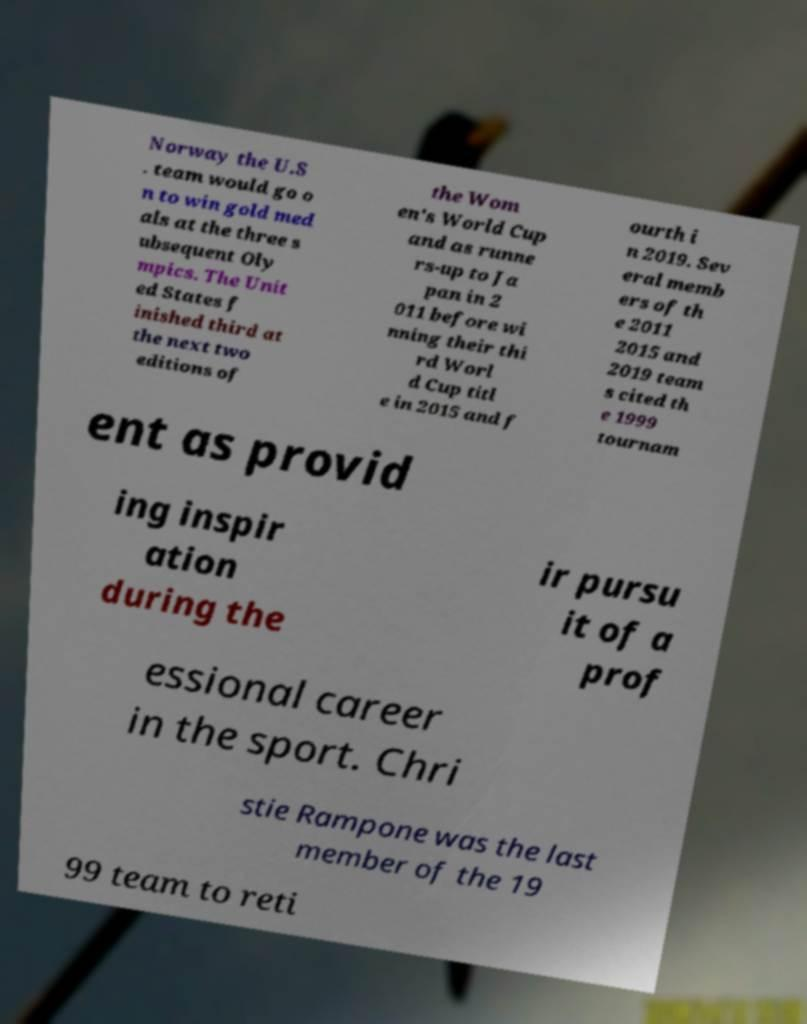I need the written content from this picture converted into text. Can you do that? Norway the U.S . team would go o n to win gold med als at the three s ubsequent Oly mpics. The Unit ed States f inished third at the next two editions of the Wom en's World Cup and as runne rs-up to Ja pan in 2 011 before wi nning their thi rd Worl d Cup titl e in 2015 and f ourth i n 2019. Sev eral memb ers of th e 2011 2015 and 2019 team s cited th e 1999 tournam ent as provid ing inspir ation during the ir pursu it of a prof essional career in the sport. Chri stie Rampone was the last member of the 19 99 team to reti 